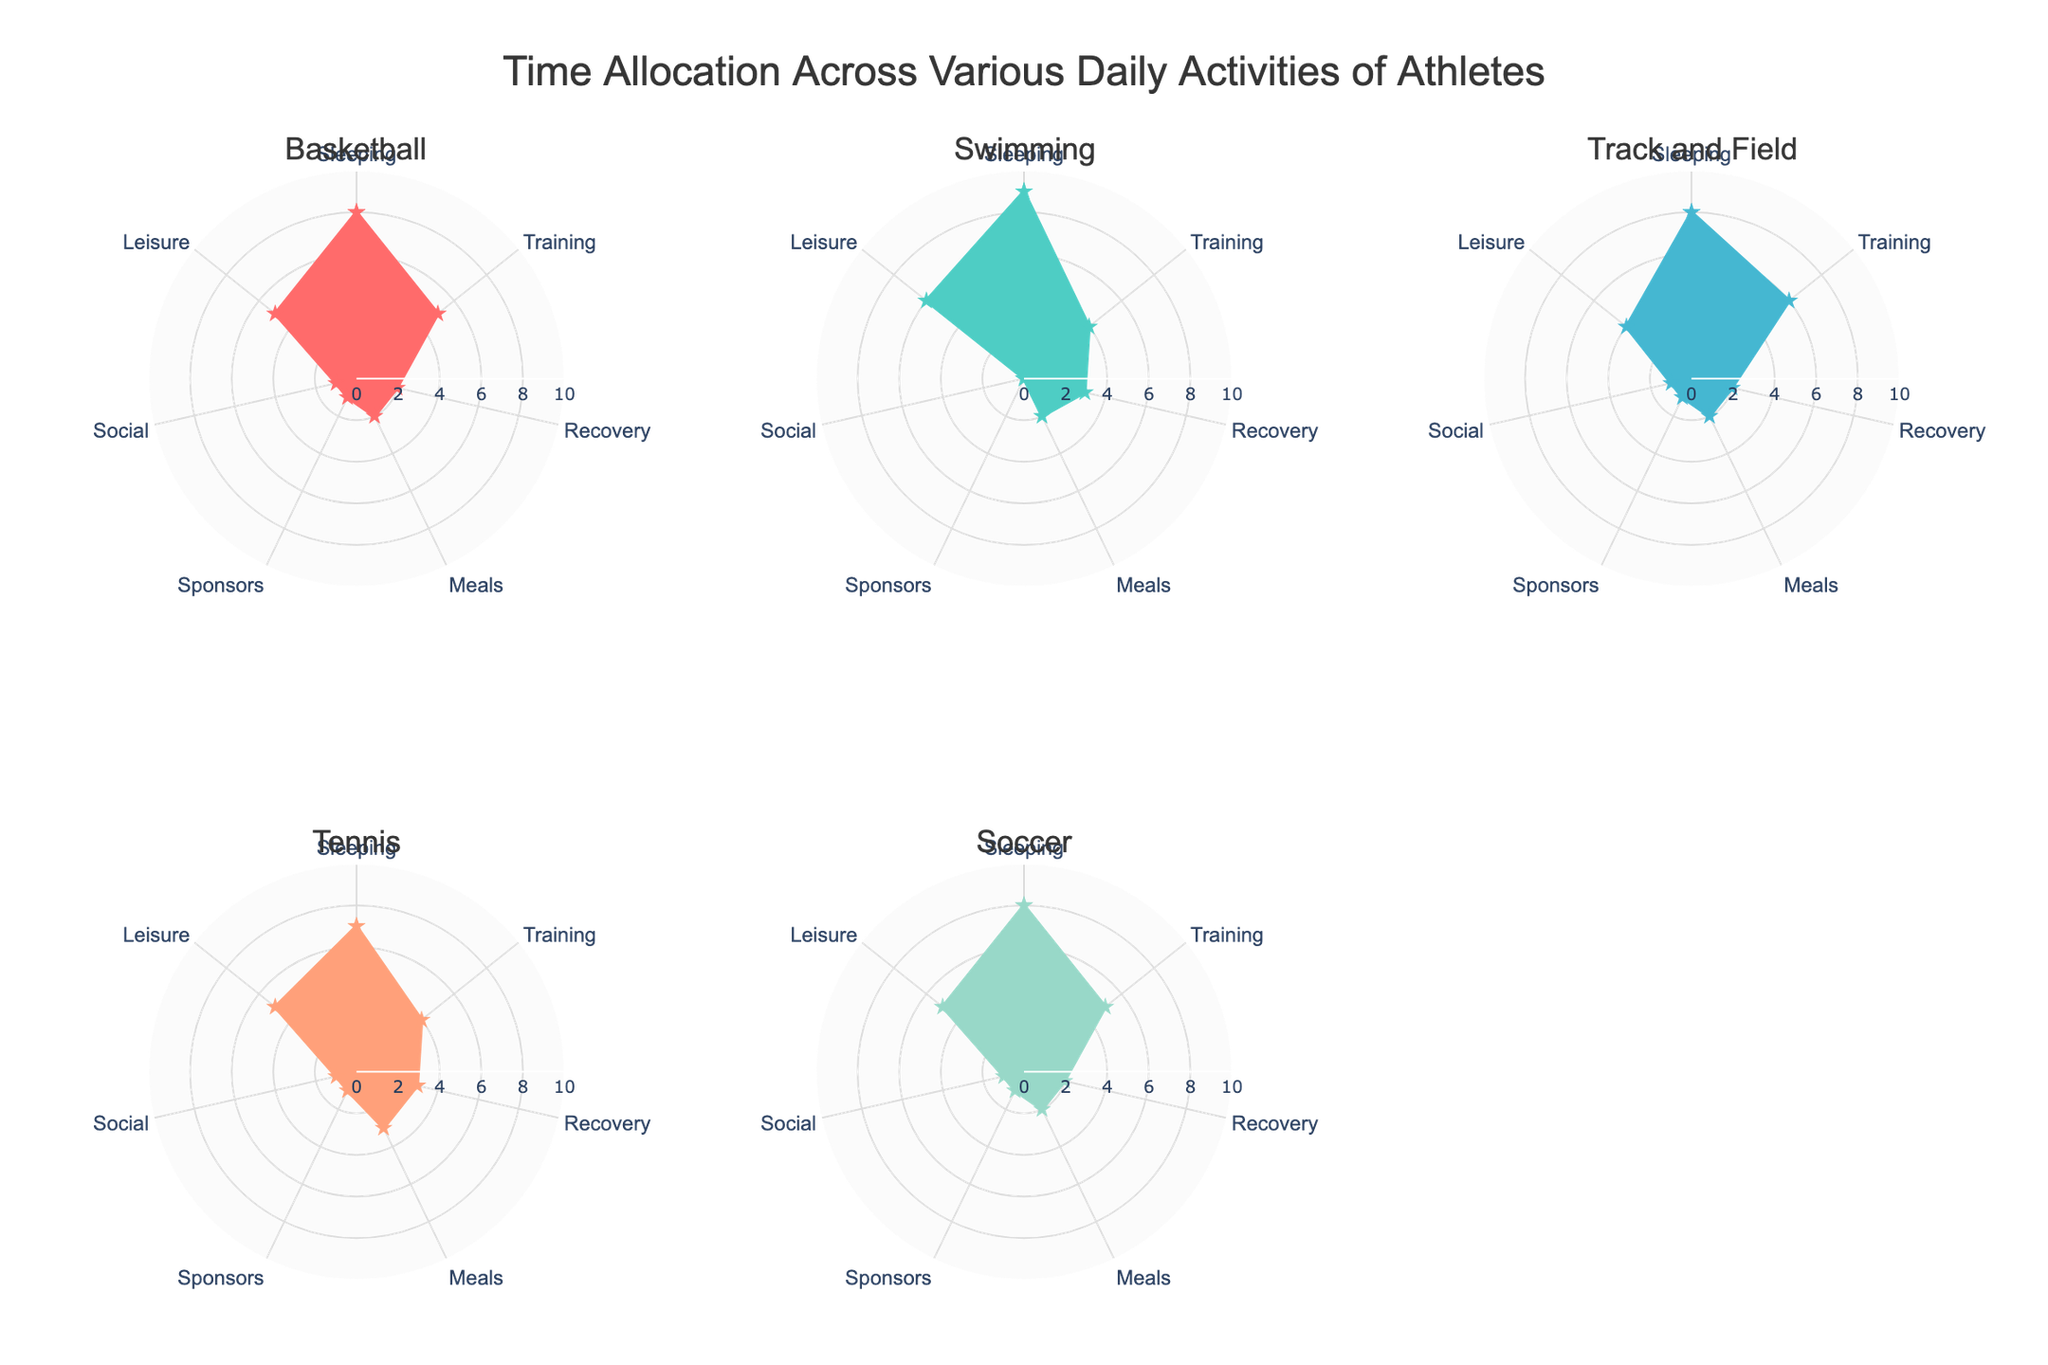What is the title of the figure? At the top of the figure, the title is displayed as "Time Allocation Across Various Daily Activities of Athletes". You can see this text prominently positioned in a larger font size compared to other elements.
Answer: Time Allocation Across Various Daily Activities of Athletes Which activity is allocated the most time for Swimming in the polar chart? By looking at the polar chart for Swimming, you can see that the longest radial line corresponds to the "Sleeping" category, indicating that Swimming has the most time allocated to Sleeping.
Answer: Sleeping How much time is allocated to Training for Track and Field compared to Basketball? By examining the polar charts for Track and Field and Basketball, you see that Track and Field allocates 6 hours to Training while Basketball allocates 5 hours to Training. A direct comparison indicates that Track and Field has 1 more hour allocated to Training than Basketball.
Answer: 1 hour more What's the combined amount of time spent on Meals across all activities? Sum the values for the Meals category across all activities: Basketball (2), Swimming (2), Track and Field (2), Tennis (3), and Soccer (2). Adding these together gives 2 + 2 + 2 + 3 + 2 = 11 hours.
Answer: 11 hours Which sport spends equal amounts of time on Recovery and Meals? Look at the polar charts and compare the time allocated to Recovery and Meals for each sport. You find that Soccer allocates 2 hours to Recovery and 2 hours to Meals, indicating equal time.
Answer: Soccer What is the difference in the time allocated to Leisure between Tennis and Swimming? By examining the polar charts, you see that Tennis allocates 5 hours to Leisure while Swimming allocates 6 hours. The difference is 6 - 5 = 1 hour.
Answer: 1 hour Which activity shows the least time allocated to Sponsorship commitments? Looking at all the polar charts, you can see that Swimming has zero hours allocated to Sponsors, which is the least amount of time compared to other activities with some hours allocated.
Answer: Swimming What's the average time spent on Social activities across all the sports? Sum the time allocated to Social activities for all sports: Basketball (1), Swimming (0), Track and Field (1), Tennis (1), and Soccer (1). The total is 1 + 0 + 1 + 1 + 1 = 4. There are 5 sports, so the average is 4/5 = 0.8 hours.
Answer: 0.8 hours 